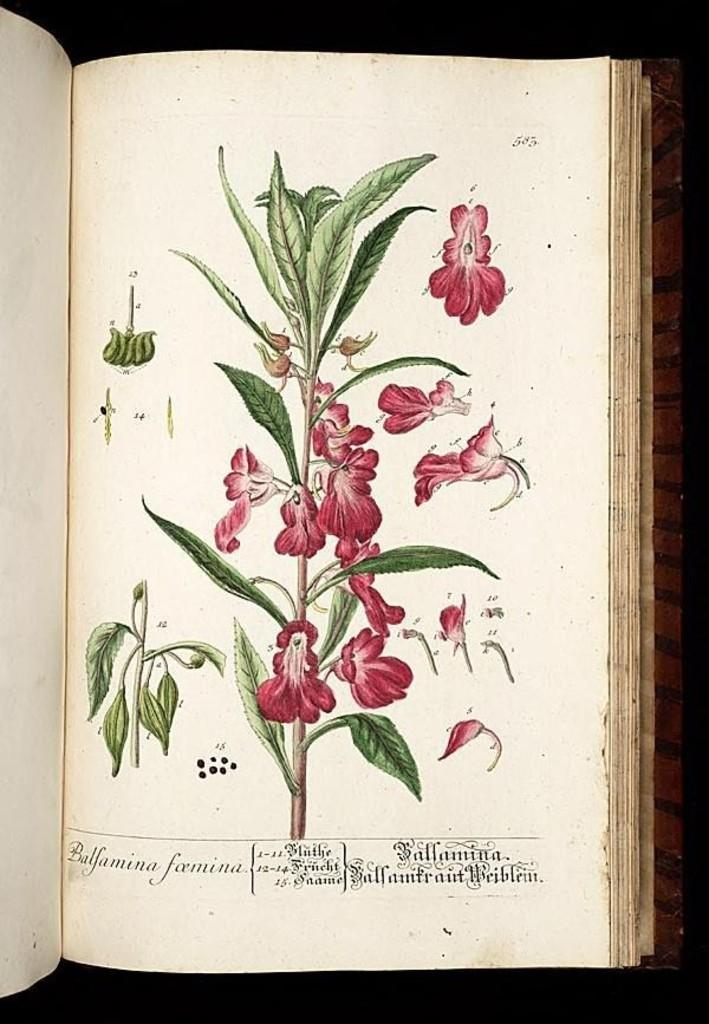What object is visible in the center of the image? There is a book in the image, and it is in the center. Where is the book located? The book is placed on a table. What type of pan is used to cook the thing in the image? There is no pan or thing present in the image; it only features a book placed on a table. 